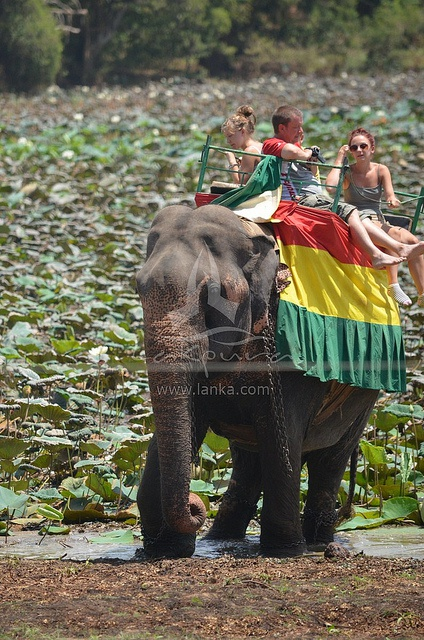Describe the objects in this image and their specific colors. I can see elephant in black, gray, darkgray, and olive tones, people in black, ivory, and gray tones, people in black, gray, brown, and tan tones, people in black, lightgray, gray, brown, and darkgray tones, and people in black, brown, gray, and maroon tones in this image. 